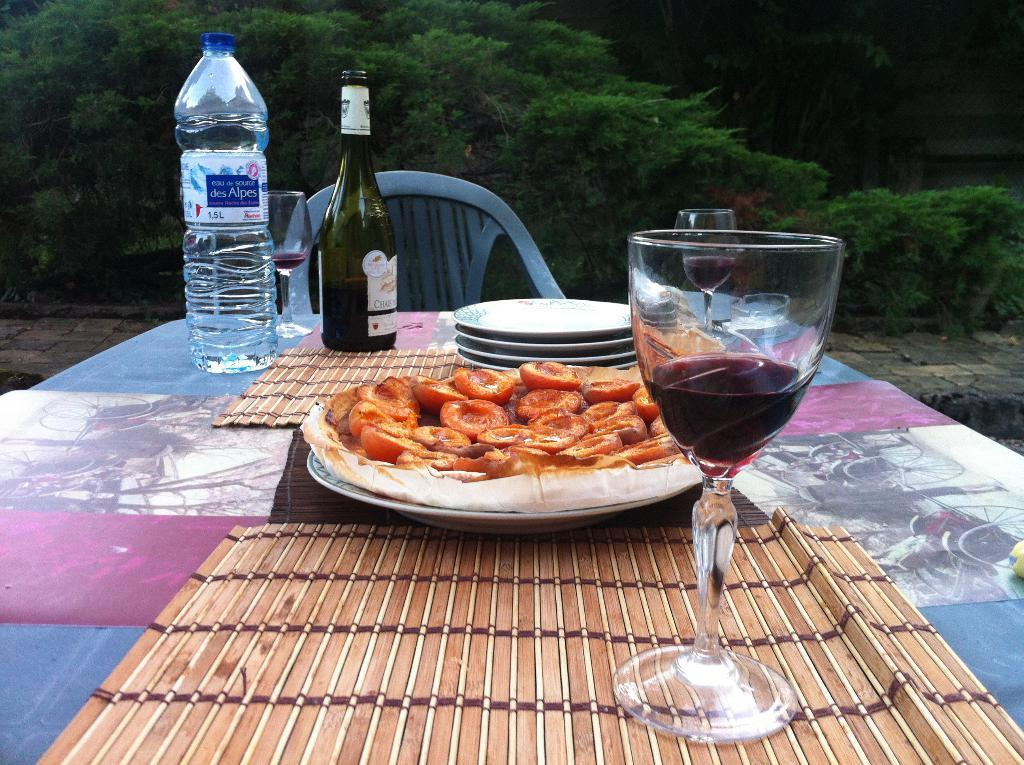What is present on the table in the image? There is food, an alcohol bottle, a water bottle, and a glass with wine on the table. What type of beverage is in the glass on the table? There is wine in a glass on the table. What other type of beverage is visible on the table? There is a water bottle on the table. What type of sweater is the steel wearing in the image? There is no person wearing a sweater in the image; it only features a table with various items on it. 